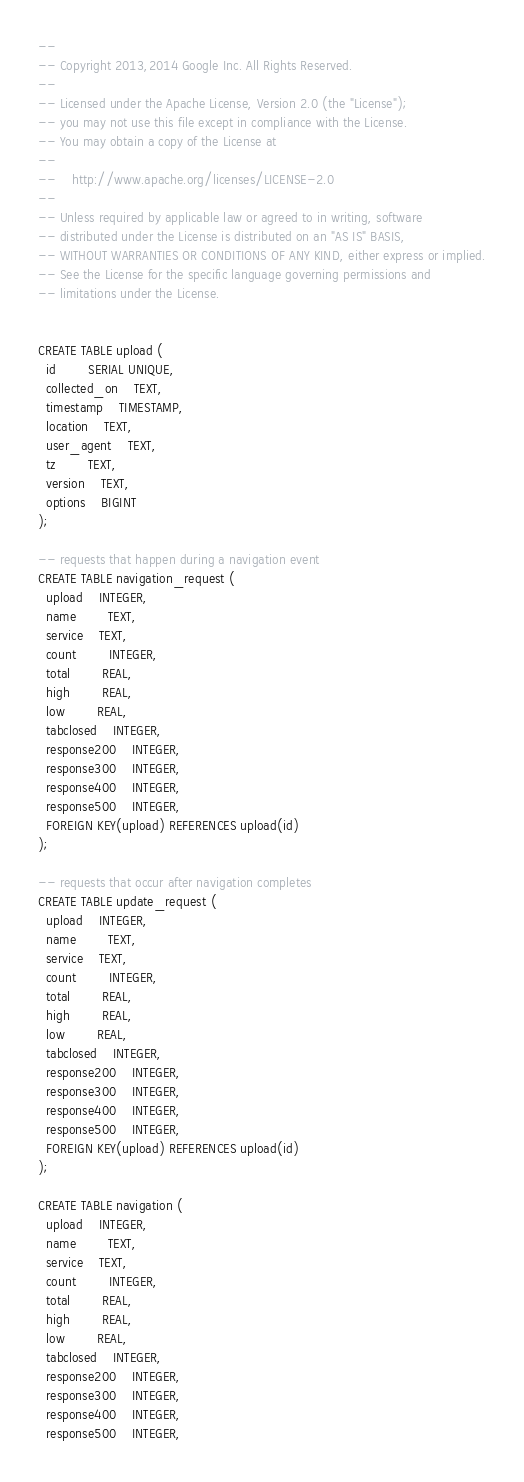Convert code to text. <code><loc_0><loc_0><loc_500><loc_500><_SQL_>--
-- Copyright 2013,2014 Google Inc. All Rights Reserved.
--
-- Licensed under the Apache License, Version 2.0 (the "License");
-- you may not use this file except in compliance with the License.
-- You may obtain a copy of the License at
--
--    http://www.apache.org/licenses/LICENSE-2.0
--
-- Unless required by applicable law or agreed to in writing, software
-- distributed under the License is distributed on an "AS IS" BASIS,
-- WITHOUT WARRANTIES OR CONDITIONS OF ANY KIND, either express or implied.
-- See the License for the specific language governing permissions and
-- limitations under the License.


CREATE TABLE upload (
  id		SERIAL UNIQUE,
  collected_on	TEXT,
  timestamp	TIMESTAMP,
  location	TEXT,
  user_agent	TEXT,
  tz		TEXT,
  version	TEXT,
  options	BIGINT
);

-- requests that happen during a navigation event
CREATE TABLE navigation_request (
  upload	INTEGER,
  name		TEXT,
  service	TEXT,
  count		INTEGER,
  total		REAL,
  high		REAL,
  low		REAL,
  tabclosed	INTEGER,
  response200	INTEGER,
  response300	INTEGER,
  response400	INTEGER,
  response500	INTEGER,
  FOREIGN KEY(upload) REFERENCES upload(id)
);

-- requests that occur after navigation completes
CREATE TABLE update_request (
  upload	INTEGER,
  name		TEXT,
  service	TEXT,
  count		INTEGER,
  total		REAL,
  high		REAL,
  low		REAL,
  tabclosed	INTEGER,
  response200	INTEGER,
  response300	INTEGER,
  response400	INTEGER,
  response500	INTEGER,
  FOREIGN KEY(upload) REFERENCES upload(id)
);

CREATE TABLE navigation (
  upload	INTEGER,
  name		TEXT,
  service	TEXT,
  count		INTEGER,
  total		REAL,
  high		REAL,
  low		REAL,
  tabclosed	INTEGER,
  response200	INTEGER,
  response300	INTEGER,
  response400	INTEGER,
  response500	INTEGER,</code> 